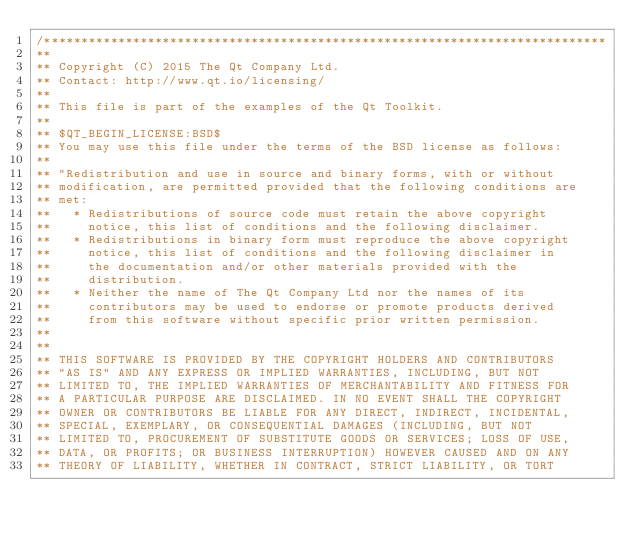Convert code to text. <code><loc_0><loc_0><loc_500><loc_500><_C++_>/****************************************************************************
**
** Copyright (C) 2015 The Qt Company Ltd.
** Contact: http://www.qt.io/licensing/
**
** This file is part of the examples of the Qt Toolkit.
**
** $QT_BEGIN_LICENSE:BSD$
** You may use this file under the terms of the BSD license as follows:
**
** "Redistribution and use in source and binary forms, with or without
** modification, are permitted provided that the following conditions are
** met:
**   * Redistributions of source code must retain the above copyright
**     notice, this list of conditions and the following disclaimer.
**   * Redistributions in binary form must reproduce the above copyright
**     notice, this list of conditions and the following disclaimer in
**     the documentation and/or other materials provided with the
**     distribution.
**   * Neither the name of The Qt Company Ltd nor the names of its
**     contributors may be used to endorse or promote products derived
**     from this software without specific prior written permission.
**
**
** THIS SOFTWARE IS PROVIDED BY THE COPYRIGHT HOLDERS AND CONTRIBUTORS
** "AS IS" AND ANY EXPRESS OR IMPLIED WARRANTIES, INCLUDING, BUT NOT
** LIMITED TO, THE IMPLIED WARRANTIES OF MERCHANTABILITY AND FITNESS FOR
** A PARTICULAR PURPOSE ARE DISCLAIMED. IN NO EVENT SHALL THE COPYRIGHT
** OWNER OR CONTRIBUTORS BE LIABLE FOR ANY DIRECT, INDIRECT, INCIDENTAL,
** SPECIAL, EXEMPLARY, OR CONSEQUENTIAL DAMAGES (INCLUDING, BUT NOT
** LIMITED TO, PROCUREMENT OF SUBSTITUTE GOODS OR SERVICES; LOSS OF USE,
** DATA, OR PROFITS; OR BUSINESS INTERRUPTION) HOWEVER CAUSED AND ON ANY
** THEORY OF LIABILITY, WHETHER IN CONTRACT, STRICT LIABILITY, OR TORT</code> 